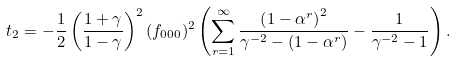Convert formula to latex. <formula><loc_0><loc_0><loc_500><loc_500>& t _ { 2 } = - \frac { 1 } { 2 } \left ( \frac { 1 + \gamma } { 1 - \gamma } \right ) ^ { 2 } ( f _ { 0 0 0 } ) ^ { 2 } \left ( \sum _ { r = 1 } ^ { \infty } \frac { \left ( 1 - \alpha ^ { r } \right ) ^ { 2 } } { \gamma ^ { - 2 } - \left ( 1 - \alpha ^ { r } \right ) } - \frac { 1 } { \gamma ^ { - 2 } - 1 } \right ) .</formula> 